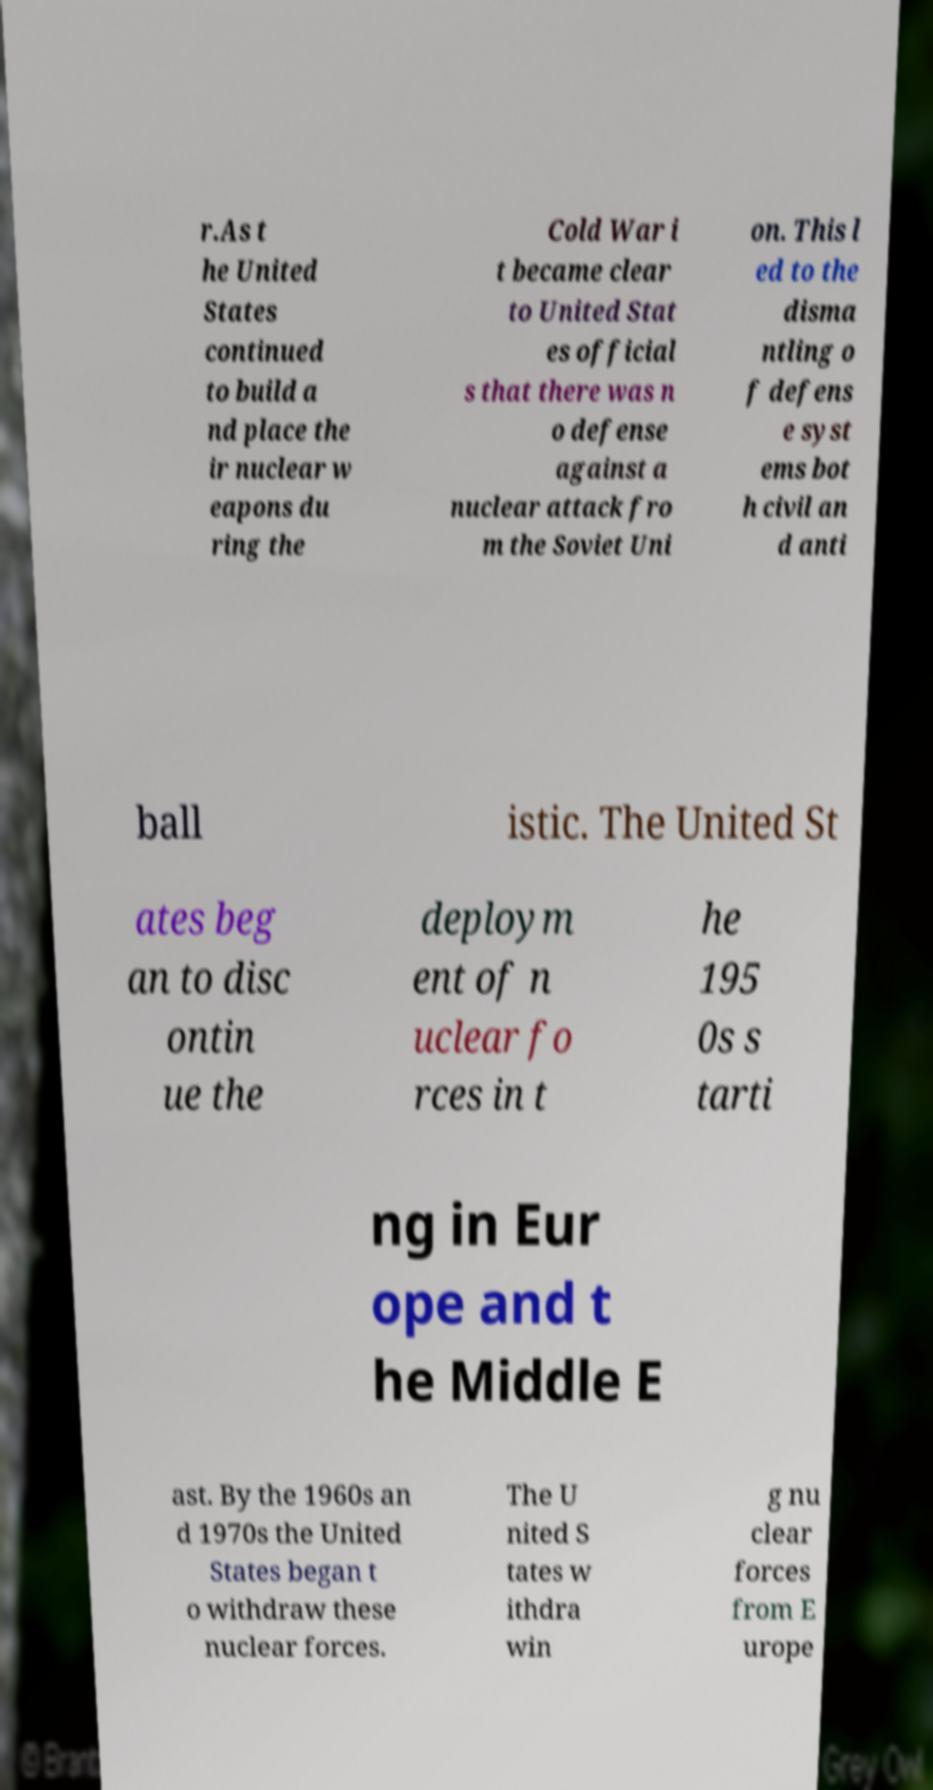I need the written content from this picture converted into text. Can you do that? r.As t he United States continued to build a nd place the ir nuclear w eapons du ring the Cold War i t became clear to United Stat es official s that there was n o defense against a nuclear attack fro m the Soviet Uni on. This l ed to the disma ntling o f defens e syst ems bot h civil an d anti ball istic. The United St ates beg an to disc ontin ue the deploym ent of n uclear fo rces in t he 195 0s s tarti ng in Eur ope and t he Middle E ast. By the 1960s an d 1970s the United States began t o withdraw these nuclear forces. The U nited S tates w ithdra win g nu clear forces from E urope 